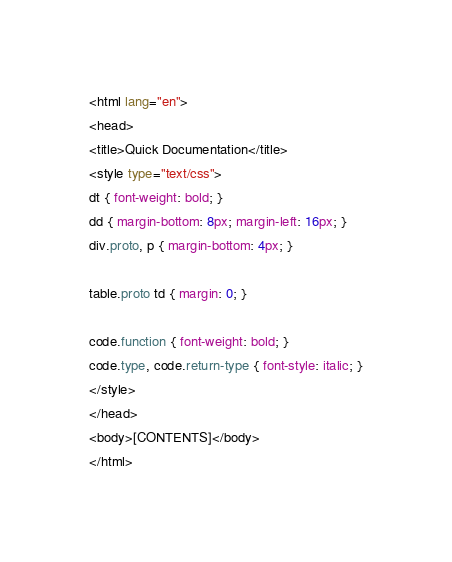<code> <loc_0><loc_0><loc_500><loc_500><_HTML_><html lang="en">
<head>
<title>Quick Documentation</title>
<style type="text/css">
dt { font-weight: bold; }
dd { margin-bottom: 8px; margin-left: 16px; }
div.proto, p { margin-bottom: 4px; }

table.proto td { margin: 0; }

code.function { font-weight: bold; }
code.type, code.return-type { font-style: italic; }
</style>
</head>
<body>[CONTENTS]</body>
</html>
</code> 